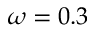Convert formula to latex. <formula><loc_0><loc_0><loc_500><loc_500>\omega = 0 . 3</formula> 